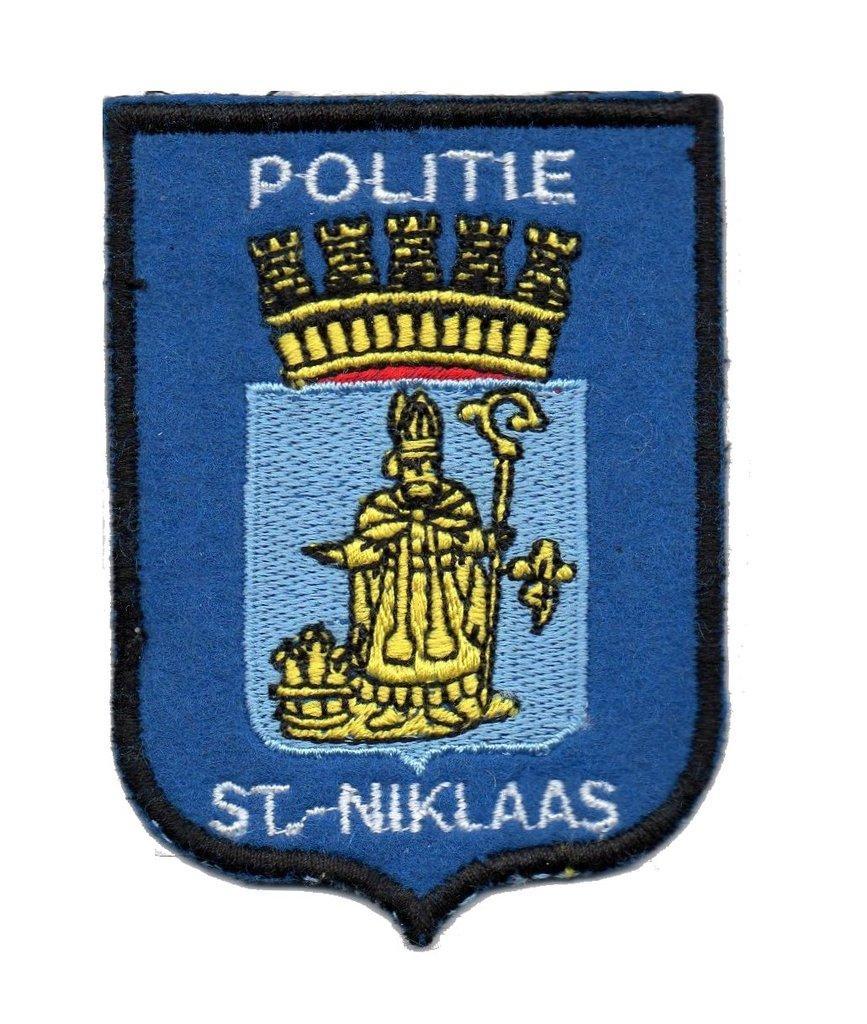Could you give a brief overview of what you see in this image? In this picture I can see a blue color batch with some text and a picture and I can see white color background. 